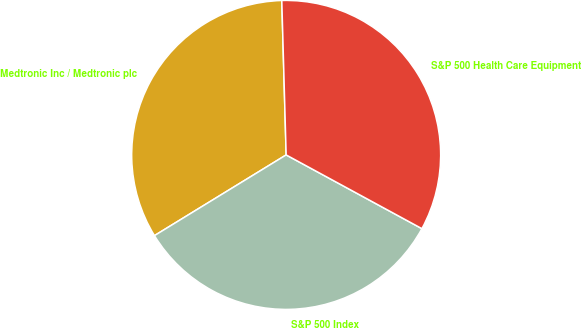Convert chart to OTSL. <chart><loc_0><loc_0><loc_500><loc_500><pie_chart><fcel>Medtronic Inc / Medtronic plc<fcel>S&P 500 Index<fcel>S&P 500 Health Care Equipment<nl><fcel>33.3%<fcel>33.33%<fcel>33.37%<nl></chart> 